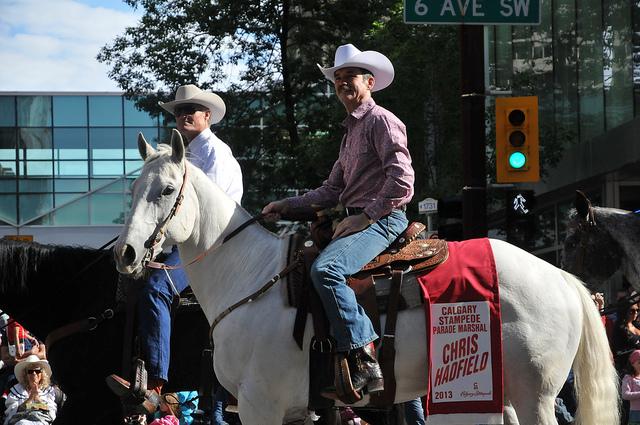Does the horse like being in the parade?
Concise answer only. Yes. Are they taking a break?
Quick response, please. No. What does the sign on the horse say?
Concise answer only. Chris hadfield. What color is the horse?
Keep it brief. White. 